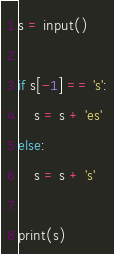Convert code to text. <code><loc_0><loc_0><loc_500><loc_500><_Python_>s = input()

if s[-1] == 's':
    s = s + 'es'
else:
    s = s + 's'

print(s)</code> 